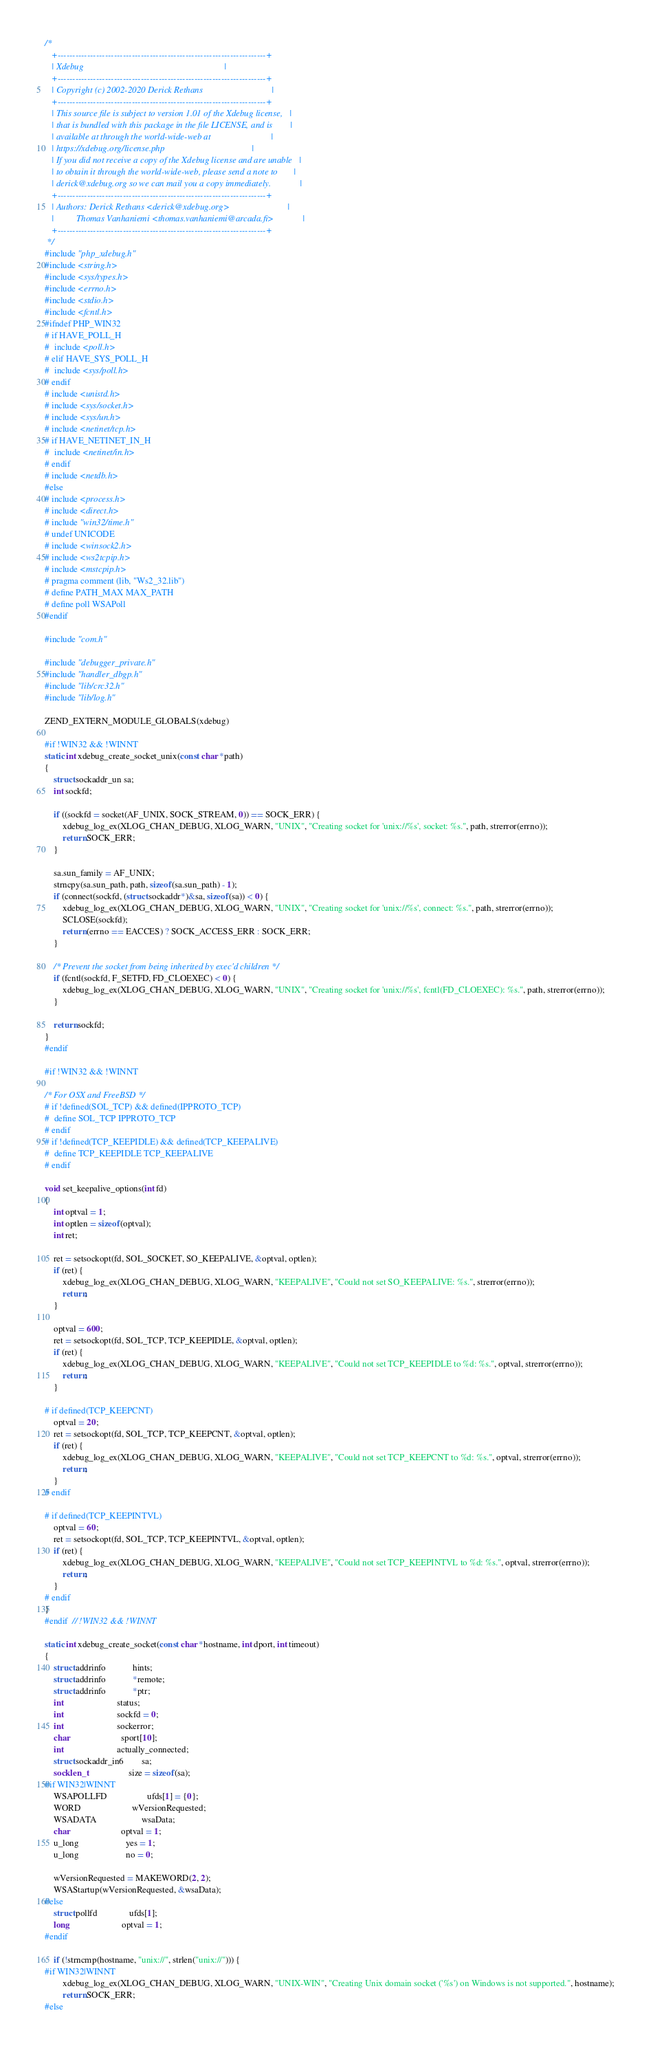Convert code to text. <code><loc_0><loc_0><loc_500><loc_500><_C_>/*
   +----------------------------------------------------------------------+
   | Xdebug                                                               |
   +----------------------------------------------------------------------+
   | Copyright (c) 2002-2020 Derick Rethans                               |
   +----------------------------------------------------------------------+
   | This source file is subject to version 1.01 of the Xdebug license,   |
   | that is bundled with this package in the file LICENSE, and is        |
   | available at through the world-wide-web at                           |
   | https://xdebug.org/license.php                                       |
   | If you did not receive a copy of the Xdebug license and are unable   |
   | to obtain it through the world-wide-web, please send a note to       |
   | derick@xdebug.org so we can mail you a copy immediately.             |
   +----------------------------------------------------------------------+
   | Authors: Derick Rethans <derick@xdebug.org>                          |
   |          Thomas Vanhaniemi <thomas.vanhaniemi@arcada.fi>             |
   +----------------------------------------------------------------------+
 */
#include "php_xdebug.h"
#include <string.h>
#include <sys/types.h>
#include <errno.h>
#include <stdio.h>
#include <fcntl.h>
#ifndef PHP_WIN32
# if HAVE_POLL_H
#  include <poll.h>
# elif HAVE_SYS_POLL_H
#  include <sys/poll.h>
# endif
# include <unistd.h>
# include <sys/socket.h>
# include <sys/un.h>
# include <netinet/tcp.h>
# if HAVE_NETINET_IN_H
#  include <netinet/in.h>
# endif
# include <netdb.h>
#else
# include <process.h>
# include <direct.h>
# include "win32/time.h"
# undef UNICODE
# include <winsock2.h>
# include <ws2tcpip.h>
# include <mstcpip.h>
# pragma comment (lib, "Ws2_32.lib")
# define PATH_MAX MAX_PATH
# define poll WSAPoll
#endif

#include "com.h"

#include "debugger_private.h"
#include "handler_dbgp.h"
#include "lib/crc32.h"
#include "lib/log.h"

ZEND_EXTERN_MODULE_GLOBALS(xdebug)

#if !WIN32 && !WINNT
static int xdebug_create_socket_unix(const char *path)
{
	struct sockaddr_un sa;
	int sockfd;

	if ((sockfd = socket(AF_UNIX, SOCK_STREAM, 0)) == SOCK_ERR) {
		xdebug_log_ex(XLOG_CHAN_DEBUG, XLOG_WARN, "UNIX", "Creating socket for 'unix://%s', socket: %s.", path, strerror(errno));
		return SOCK_ERR;
	}

	sa.sun_family = AF_UNIX;
	strncpy(sa.sun_path, path, sizeof(sa.sun_path) - 1);
	if (connect(sockfd, (struct sockaddr*)&sa, sizeof(sa)) < 0) {
		xdebug_log_ex(XLOG_CHAN_DEBUG, XLOG_WARN, "UNIX", "Creating socket for 'unix://%s', connect: %s.", path, strerror(errno));
		SCLOSE(sockfd);
		return (errno == EACCES) ? SOCK_ACCESS_ERR : SOCK_ERR;
	}

	/* Prevent the socket from being inherited by exec'd children */
	if (fcntl(sockfd, F_SETFD, FD_CLOEXEC) < 0) {
		xdebug_log_ex(XLOG_CHAN_DEBUG, XLOG_WARN, "UNIX", "Creating socket for 'unix://%s', fcntl(FD_CLOEXEC): %s.", path, strerror(errno));
	}

	return sockfd;
}
#endif

#if !WIN32 && !WINNT

/* For OSX and FreeBSD */
# if !defined(SOL_TCP) && defined(IPPROTO_TCP)
#  define SOL_TCP IPPROTO_TCP
# endif
# if !defined(TCP_KEEPIDLE) && defined(TCP_KEEPALIVE)
#  define TCP_KEEPIDLE TCP_KEEPALIVE
# endif

void set_keepalive_options(int fd)
{
	int optval = 1;
	int optlen = sizeof(optval);
	int ret;

	ret = setsockopt(fd, SOL_SOCKET, SO_KEEPALIVE, &optval, optlen);
	if (ret) {
		xdebug_log_ex(XLOG_CHAN_DEBUG, XLOG_WARN, "KEEPALIVE", "Could not set SO_KEEPALIVE: %s.", strerror(errno));
		return;
	}

	optval = 600;
	ret = setsockopt(fd, SOL_TCP, TCP_KEEPIDLE, &optval, optlen);
	if (ret) {
		xdebug_log_ex(XLOG_CHAN_DEBUG, XLOG_WARN, "KEEPALIVE", "Could not set TCP_KEEPIDLE to %d: %s.", optval, strerror(errno));
		return;
	}

# if defined(TCP_KEEPCNT)
	optval = 20;
	ret = setsockopt(fd, SOL_TCP, TCP_KEEPCNT, &optval, optlen);
	if (ret) {
		xdebug_log_ex(XLOG_CHAN_DEBUG, XLOG_WARN, "KEEPALIVE", "Could not set TCP_KEEPCNT to %d: %s.", optval, strerror(errno));
		return;
	}
# endif

# if defined(TCP_KEEPINTVL)
	optval = 60;
	ret = setsockopt(fd, SOL_TCP, TCP_KEEPINTVL, &optval, optlen);
	if (ret) {
		xdebug_log_ex(XLOG_CHAN_DEBUG, XLOG_WARN, "KEEPALIVE", "Could not set TCP_KEEPINTVL to %d: %s.", optval, strerror(errno));
		return;
	}
# endif
}
#endif  // !WIN32 && !WINNT

static int xdebug_create_socket(const char *hostname, int dport, int timeout)
{
	struct addrinfo            hints;
	struct addrinfo            *remote;
	struct addrinfo            *ptr;
	int                        status;
	int                        sockfd = 0;
	int                        sockerror;
	char                       sport[10];
	int                        actually_connected;
	struct sockaddr_in6        sa;
	socklen_t                  size = sizeof(sa);
#if WIN32|WINNT
	WSAPOLLFD                  ufds[1] = {0};
	WORD                       wVersionRequested;
	WSADATA                    wsaData;
	char                       optval = 1;
	u_long                     yes = 1;
	u_long                     no = 0;

	wVersionRequested = MAKEWORD(2, 2);
	WSAStartup(wVersionRequested, &wsaData);
#else
	struct pollfd              ufds[1];
	long                       optval = 1;
#endif

	if (!strncmp(hostname, "unix://", strlen("unix://"))) {
#if WIN32|WINNT
		xdebug_log_ex(XLOG_CHAN_DEBUG, XLOG_WARN, "UNIX-WIN", "Creating Unix domain socket ('%s') on Windows is not supported.", hostname);
		return SOCK_ERR;
#else</code> 